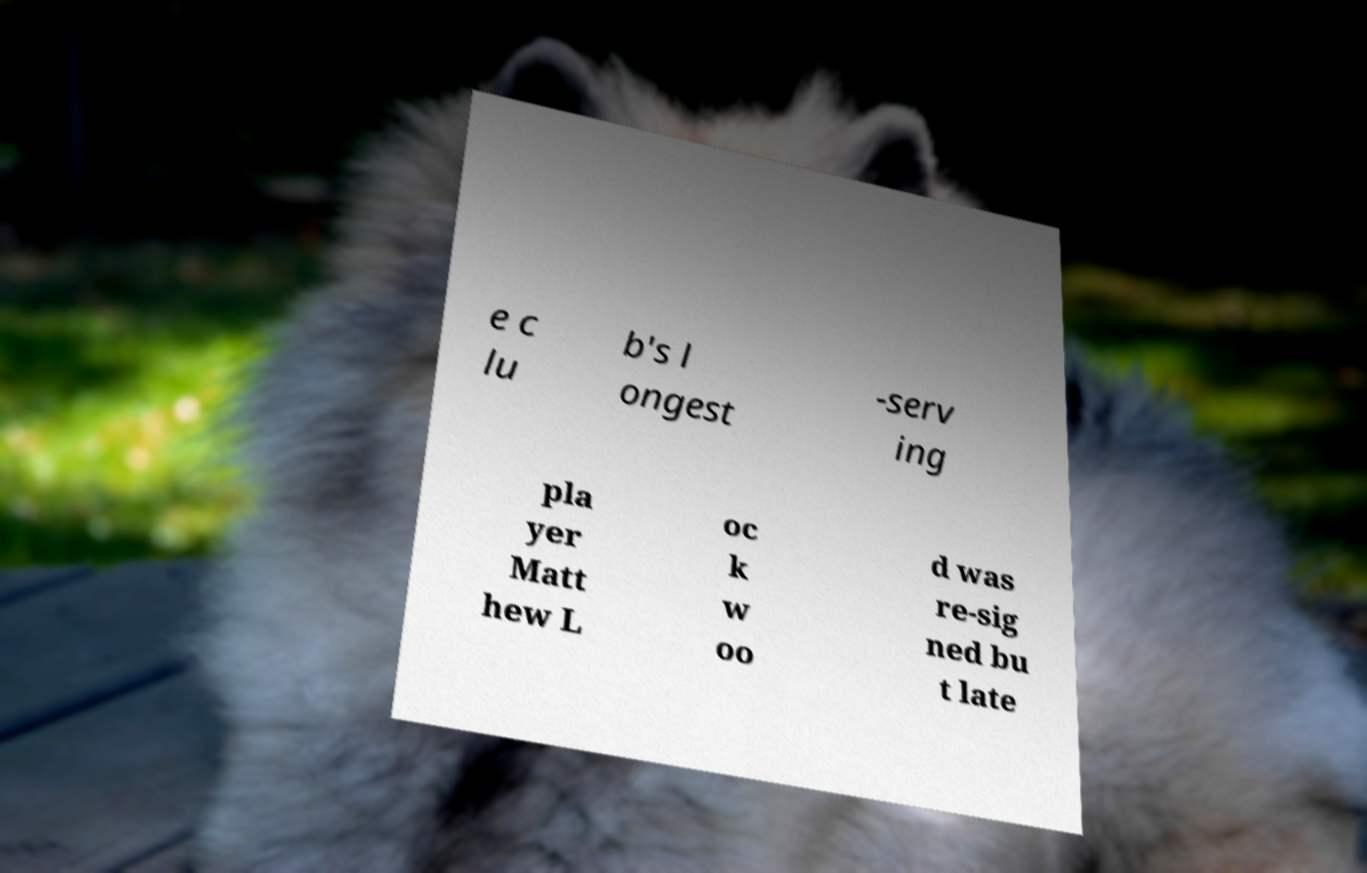I need the written content from this picture converted into text. Can you do that? e c lu b's l ongest -serv ing pla yer Matt hew L oc k w oo d was re-sig ned bu t late 